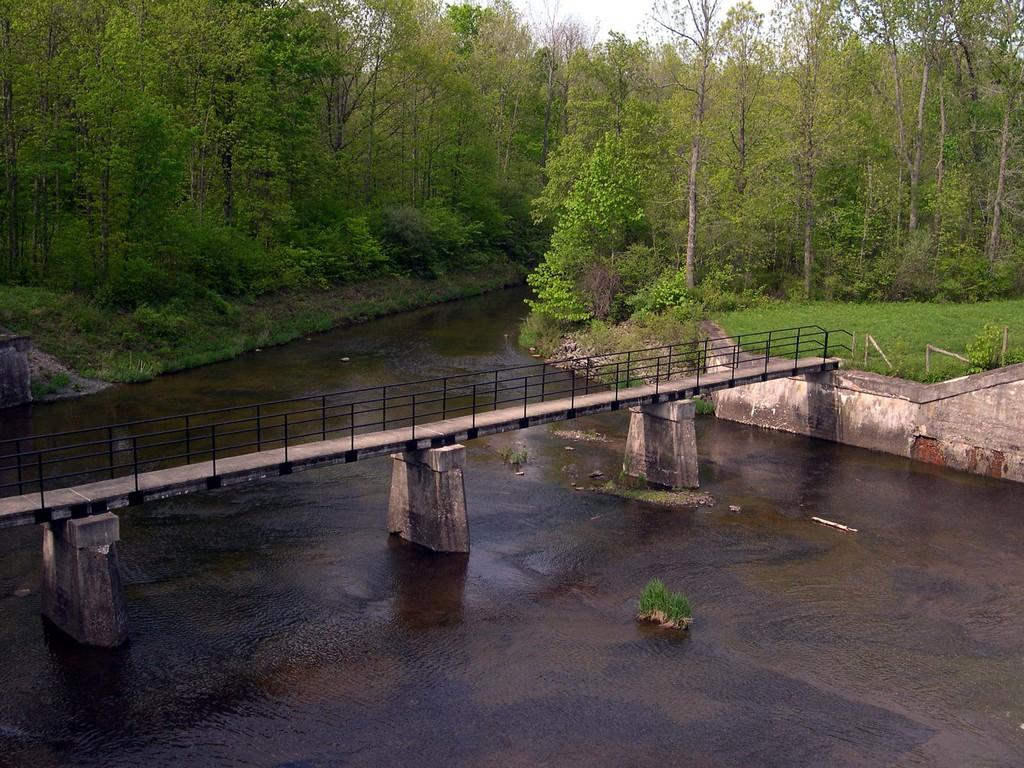What type of natural feature is present in the image? There is a river in the image. What is on the river? There is grass on the river. What structure is present above the river? There is a bridge above the river. What type of vegetation can be seen in the background of the image? There is grass and trees in the background of the image. Can you see a dime floating on the river in the image? There is no dime present in the image; it only features a river, grass, a bridge, and vegetation in the background. 